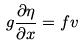<formula> <loc_0><loc_0><loc_500><loc_500>g \frac { \partial \eta } { \partial x } = f v</formula> 